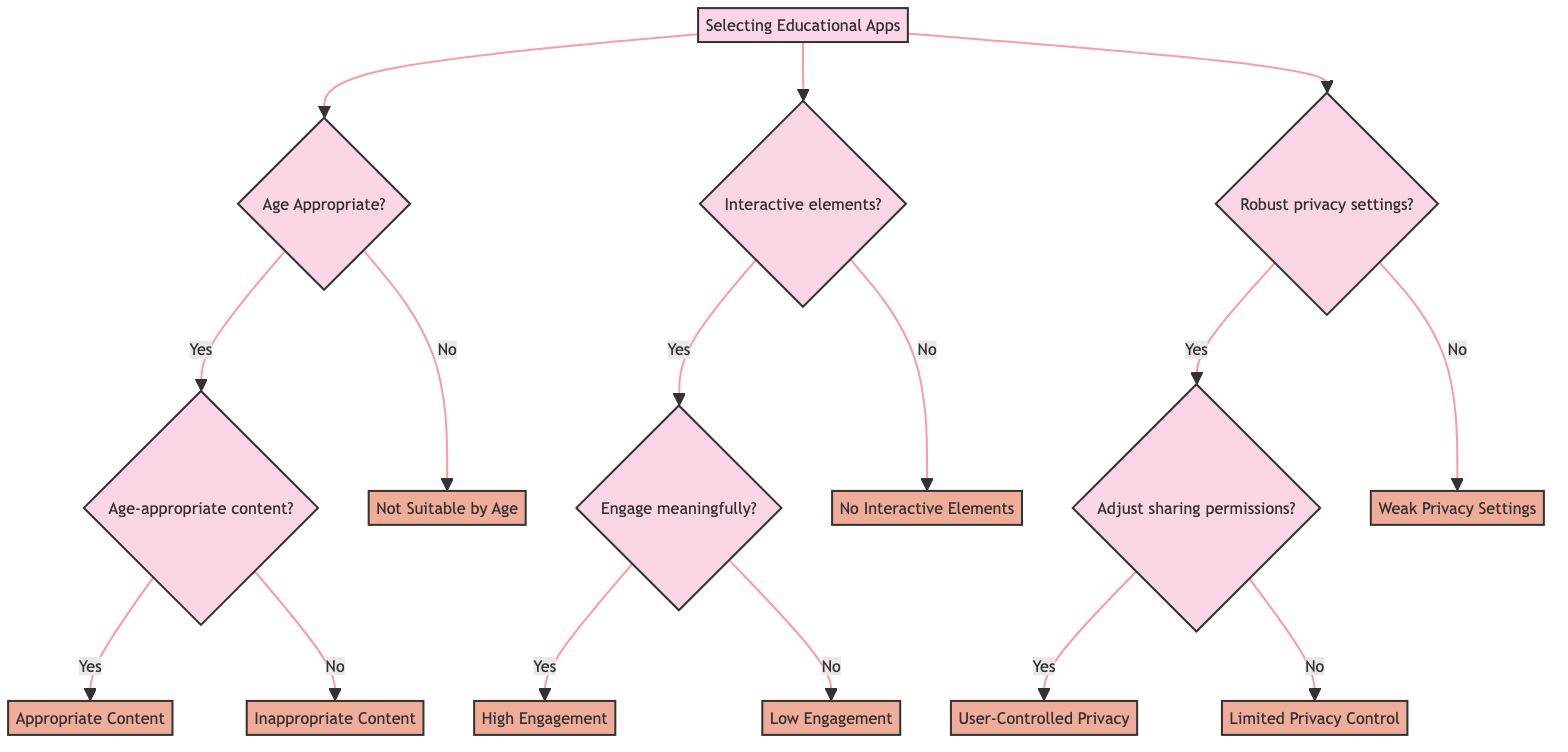What is the first question in the Age Appropriateness branch? The first question in the Age Appropriateness branch is "Is the app designed for the child's age group?" I can find this at the beginning of the Age Appropriateness section of the decision tree.
Answer: Is the app designed for the child's age group? How many endpoints are in the Engagement section? The Engagement section has three endpoints: "No Interactive Elements," "High Engagement," and "Low Engagement." Each of these endpoints is where the flow concludes for different outcomes in this section.
Answer: Three endpoints What happens if the child’s age group is not suitable for the app? If the child's age group is not suitable for the app, the outcome will be "Not Suitable by Age." This is determined by following the first yes/no question in the Age Appropriateness branch that leads directly to this endpoint.
Answer: Not Suitable by Age If an app includes interactive elements but does not engage the child meaningfully, what is the result? The result in this case would be "Low Engagement." This is found after answering "Yes" to the interactive elements question and "No" to the engagement question, leading directly to this endpoint.
Answer: Low Engagement Which endpoint indicates weak privacy settings? The endpoint that indicates weak privacy settings is "Weak Privacy Settings." It is reached by selecting "No" in response to the question regarding robust privacy settings.
Answer: Weak Privacy Settings How does one achieve user-controlled privacy settings according to the diagram? To achieve user-controlled privacy settings, the app must first provide robust privacy settings, and then the user must be able to easily adjust sharing permissions. This is the flow for reaching the endpoint labeled "User-Controlled Privacy."
Answer: User-Controlled Privacy What is the consequence if an app does not have robust privacy settings? The consequence is "Weak Privacy Settings." This outcome is reached by directly answering "No" to the question regarding robust privacy settings.
Answer: Weak Privacy Settings What are the two types of content outcomes in the Age Appropriateness section? The two types of content outcomes in the Age Appropriateness section are "Appropriate Content" and "Inappropriate Content." These endpoints are reached based on the age appropriateness questions and their answers.
Answer: Appropriate Content and Inappropriate Content 